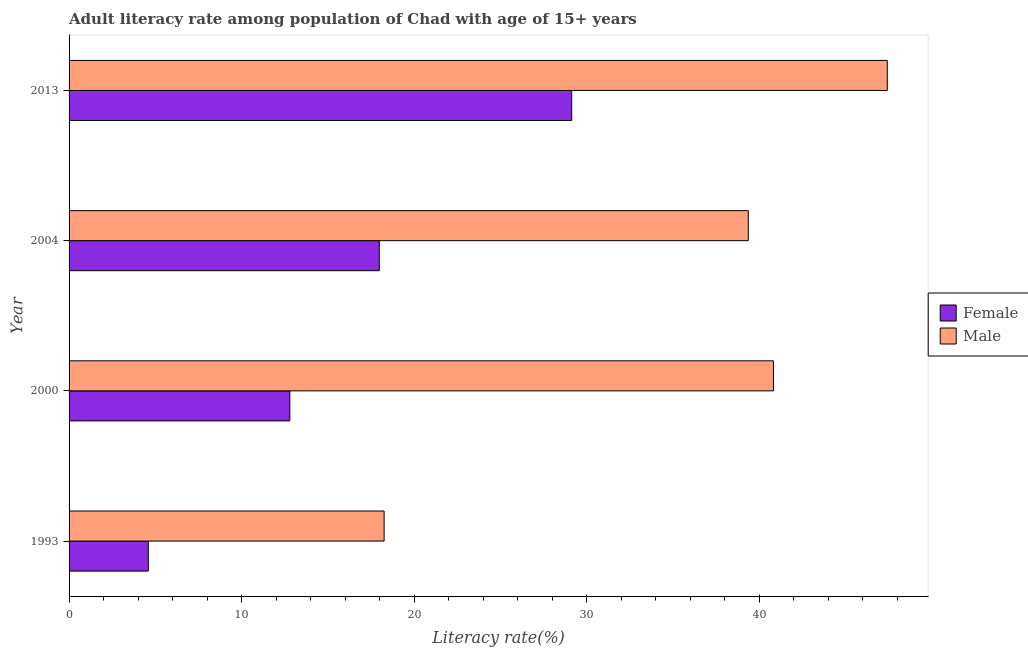How many groups of bars are there?
Offer a very short reply. 4. How many bars are there on the 2nd tick from the bottom?
Your answer should be compact. 2. What is the label of the 4th group of bars from the top?
Keep it short and to the point. 1993. In how many cases, is the number of bars for a given year not equal to the number of legend labels?
Ensure brevity in your answer.  0. What is the male adult literacy rate in 2004?
Your answer should be compact. 39.37. Across all years, what is the maximum female adult literacy rate?
Offer a very short reply. 29.13. Across all years, what is the minimum female adult literacy rate?
Make the answer very short. 4.59. In which year was the male adult literacy rate maximum?
Your response must be concise. 2013. In which year was the male adult literacy rate minimum?
Provide a succinct answer. 1993. What is the total female adult literacy rate in the graph?
Offer a terse response. 64.5. What is the difference between the male adult literacy rate in 2004 and that in 2013?
Offer a very short reply. -8.06. What is the difference between the male adult literacy rate in 2000 and the female adult literacy rate in 2004?
Offer a very short reply. 22.85. What is the average female adult literacy rate per year?
Provide a succinct answer. 16.12. In the year 2004, what is the difference between the female adult literacy rate and male adult literacy rate?
Ensure brevity in your answer.  -21.39. In how many years, is the female adult literacy rate greater than 34 %?
Give a very brief answer. 0. What is the ratio of the female adult literacy rate in 2000 to that in 2013?
Make the answer very short. 0.44. Is the female adult literacy rate in 1993 less than that in 2000?
Your answer should be very brief. Yes. What is the difference between the highest and the second highest male adult literacy rate?
Keep it short and to the point. 6.6. What is the difference between the highest and the lowest male adult literacy rate?
Make the answer very short. 29.16. In how many years, is the male adult literacy rate greater than the average male adult literacy rate taken over all years?
Your answer should be compact. 3. Is the sum of the male adult literacy rate in 2004 and 2013 greater than the maximum female adult literacy rate across all years?
Provide a succinct answer. Yes. What does the 1st bar from the top in 2013 represents?
Keep it short and to the point. Male. What does the 2nd bar from the bottom in 1993 represents?
Your answer should be compact. Male. Are all the bars in the graph horizontal?
Give a very brief answer. Yes. Are the values on the major ticks of X-axis written in scientific E-notation?
Provide a succinct answer. No. Does the graph contain any zero values?
Your answer should be very brief. No. Does the graph contain grids?
Make the answer very short. No. Where does the legend appear in the graph?
Ensure brevity in your answer.  Center right. How are the legend labels stacked?
Provide a succinct answer. Vertical. What is the title of the graph?
Keep it short and to the point. Adult literacy rate among population of Chad with age of 15+ years. Does "Female population" appear as one of the legend labels in the graph?
Give a very brief answer. No. What is the label or title of the X-axis?
Offer a very short reply. Literacy rate(%). What is the label or title of the Y-axis?
Offer a very short reply. Year. What is the Literacy rate(%) in Female in 1993?
Offer a terse response. 4.59. What is the Literacy rate(%) of Male in 1993?
Offer a very short reply. 18.26. What is the Literacy rate(%) of Female in 2000?
Make the answer very short. 12.8. What is the Literacy rate(%) in Male in 2000?
Keep it short and to the point. 40.83. What is the Literacy rate(%) in Female in 2004?
Give a very brief answer. 17.98. What is the Literacy rate(%) in Male in 2004?
Your answer should be very brief. 39.37. What is the Literacy rate(%) in Female in 2013?
Ensure brevity in your answer.  29.13. What is the Literacy rate(%) in Male in 2013?
Your answer should be compact. 47.42. Across all years, what is the maximum Literacy rate(%) in Female?
Provide a short and direct response. 29.13. Across all years, what is the maximum Literacy rate(%) in Male?
Give a very brief answer. 47.42. Across all years, what is the minimum Literacy rate(%) of Female?
Your response must be concise. 4.59. Across all years, what is the minimum Literacy rate(%) in Male?
Give a very brief answer. 18.26. What is the total Literacy rate(%) in Female in the graph?
Offer a terse response. 64.5. What is the total Literacy rate(%) of Male in the graph?
Provide a short and direct response. 145.88. What is the difference between the Literacy rate(%) in Female in 1993 and that in 2000?
Provide a succinct answer. -8.2. What is the difference between the Literacy rate(%) of Male in 1993 and that in 2000?
Ensure brevity in your answer.  -22.57. What is the difference between the Literacy rate(%) of Female in 1993 and that in 2004?
Offer a terse response. -13.39. What is the difference between the Literacy rate(%) in Male in 1993 and that in 2004?
Offer a terse response. -21.11. What is the difference between the Literacy rate(%) in Female in 1993 and that in 2013?
Provide a short and direct response. -24.54. What is the difference between the Literacy rate(%) in Male in 1993 and that in 2013?
Give a very brief answer. -29.16. What is the difference between the Literacy rate(%) of Female in 2000 and that in 2004?
Provide a short and direct response. -5.18. What is the difference between the Literacy rate(%) in Male in 2000 and that in 2004?
Offer a terse response. 1.46. What is the difference between the Literacy rate(%) in Female in 2000 and that in 2013?
Provide a short and direct response. -16.34. What is the difference between the Literacy rate(%) in Male in 2000 and that in 2013?
Ensure brevity in your answer.  -6.6. What is the difference between the Literacy rate(%) of Female in 2004 and that in 2013?
Your response must be concise. -11.15. What is the difference between the Literacy rate(%) of Male in 2004 and that in 2013?
Provide a succinct answer. -8.06. What is the difference between the Literacy rate(%) of Female in 1993 and the Literacy rate(%) of Male in 2000?
Offer a terse response. -36.24. What is the difference between the Literacy rate(%) of Female in 1993 and the Literacy rate(%) of Male in 2004?
Provide a succinct answer. -34.78. What is the difference between the Literacy rate(%) of Female in 1993 and the Literacy rate(%) of Male in 2013?
Your answer should be compact. -42.83. What is the difference between the Literacy rate(%) in Female in 2000 and the Literacy rate(%) in Male in 2004?
Your answer should be very brief. -26.57. What is the difference between the Literacy rate(%) of Female in 2000 and the Literacy rate(%) of Male in 2013?
Give a very brief answer. -34.63. What is the difference between the Literacy rate(%) of Female in 2004 and the Literacy rate(%) of Male in 2013?
Provide a succinct answer. -29.44. What is the average Literacy rate(%) in Female per year?
Provide a short and direct response. 16.13. What is the average Literacy rate(%) in Male per year?
Your answer should be compact. 36.47. In the year 1993, what is the difference between the Literacy rate(%) of Female and Literacy rate(%) of Male?
Offer a terse response. -13.67. In the year 2000, what is the difference between the Literacy rate(%) of Female and Literacy rate(%) of Male?
Offer a terse response. -28.03. In the year 2004, what is the difference between the Literacy rate(%) in Female and Literacy rate(%) in Male?
Your response must be concise. -21.39. In the year 2013, what is the difference between the Literacy rate(%) in Female and Literacy rate(%) in Male?
Provide a succinct answer. -18.29. What is the ratio of the Literacy rate(%) of Female in 1993 to that in 2000?
Keep it short and to the point. 0.36. What is the ratio of the Literacy rate(%) in Male in 1993 to that in 2000?
Provide a succinct answer. 0.45. What is the ratio of the Literacy rate(%) in Female in 1993 to that in 2004?
Make the answer very short. 0.26. What is the ratio of the Literacy rate(%) in Male in 1993 to that in 2004?
Ensure brevity in your answer.  0.46. What is the ratio of the Literacy rate(%) in Female in 1993 to that in 2013?
Give a very brief answer. 0.16. What is the ratio of the Literacy rate(%) in Male in 1993 to that in 2013?
Give a very brief answer. 0.39. What is the ratio of the Literacy rate(%) of Female in 2000 to that in 2004?
Make the answer very short. 0.71. What is the ratio of the Literacy rate(%) in Male in 2000 to that in 2004?
Provide a short and direct response. 1.04. What is the ratio of the Literacy rate(%) of Female in 2000 to that in 2013?
Provide a succinct answer. 0.44. What is the ratio of the Literacy rate(%) of Male in 2000 to that in 2013?
Provide a succinct answer. 0.86. What is the ratio of the Literacy rate(%) in Female in 2004 to that in 2013?
Offer a very short reply. 0.62. What is the ratio of the Literacy rate(%) in Male in 2004 to that in 2013?
Provide a succinct answer. 0.83. What is the difference between the highest and the second highest Literacy rate(%) in Female?
Ensure brevity in your answer.  11.15. What is the difference between the highest and the second highest Literacy rate(%) of Male?
Provide a short and direct response. 6.6. What is the difference between the highest and the lowest Literacy rate(%) of Female?
Ensure brevity in your answer.  24.54. What is the difference between the highest and the lowest Literacy rate(%) in Male?
Offer a terse response. 29.16. 